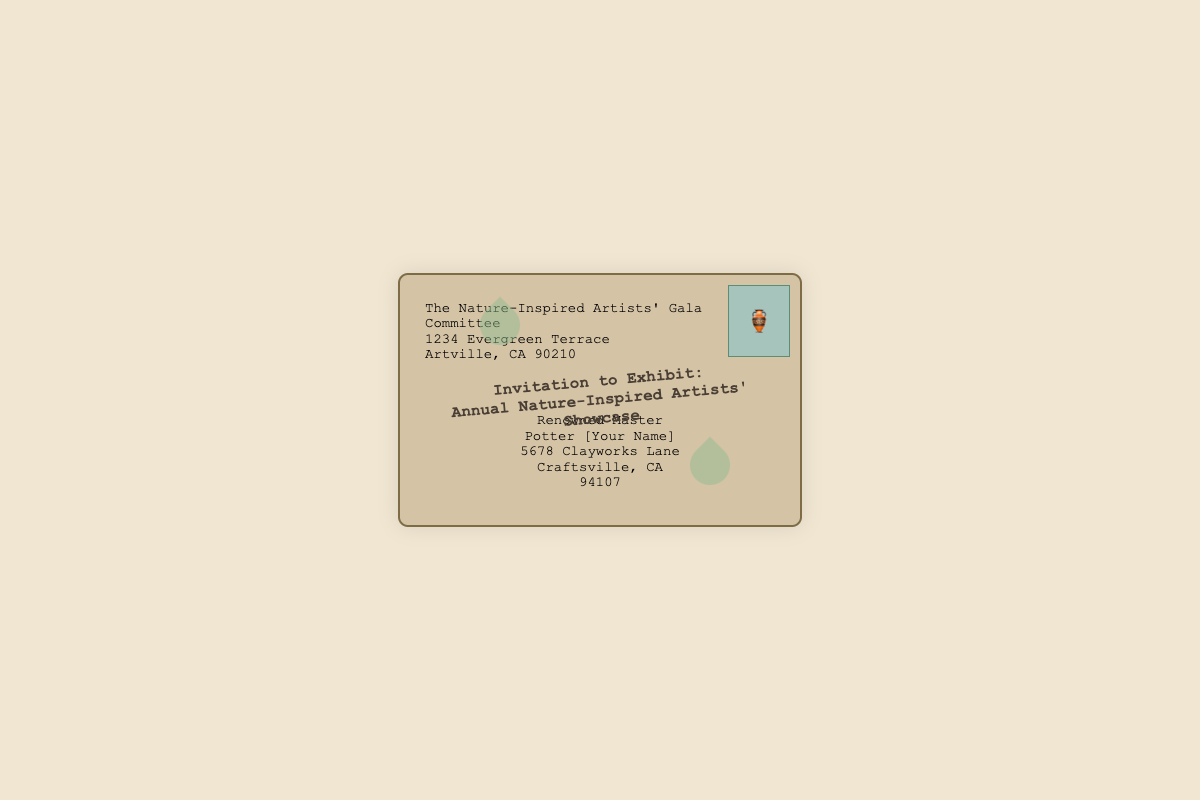What is the title of the event? The title of the event is prominently displayed in the subject section of the envelope.
Answer: Invitation to Exhibit: Annual Nature-Inspired Artists' Showcase Who is the sender of the invitation? The sender's name and address are listed at the top left of the envelope.
Answer: The Nature-Inspired Artists' Gala Committee What is the recipient's name? The recipient's name is indicated in the center of the recipient section of the envelope.
Answer: Renowned Master Potter [Your Name] Where is the sender located? The sender's address is shown in the sender section of the envelope.
Answer: 1234 Evergreen Terrace, Artville, CA 90210 What symbol is used as the stamp? The envelope features a specific symbol as its stamp, located at the top right.
Answer: 🏺 In which city is the recipient's address located? The city in the recipient's address is found in the recipient section of the envelope.
Answer: Craftsville How many leaves are illustrated on the envelope? The envelope has two decorative leaves visible in different locations.
Answer: 2 What color is used for the envelope background? The background color of the envelope is described in the style section of the document.
Answer: #d4c3a5 What is the purpose of this envelope? Analyzing the subject line and context can help determine the envelope's purpose.
Answer: Invitation to Exhibit 